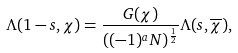Convert formula to latex. <formula><loc_0><loc_0><loc_500><loc_500>\Lambda ( 1 - s , \chi ) = \frac { G ( \chi ) } { ( ( - 1 ) ^ { a } N ) ^ { \frac { 1 } { 2 } } } \Lambda ( s , \overline { \chi } ) ,</formula> 